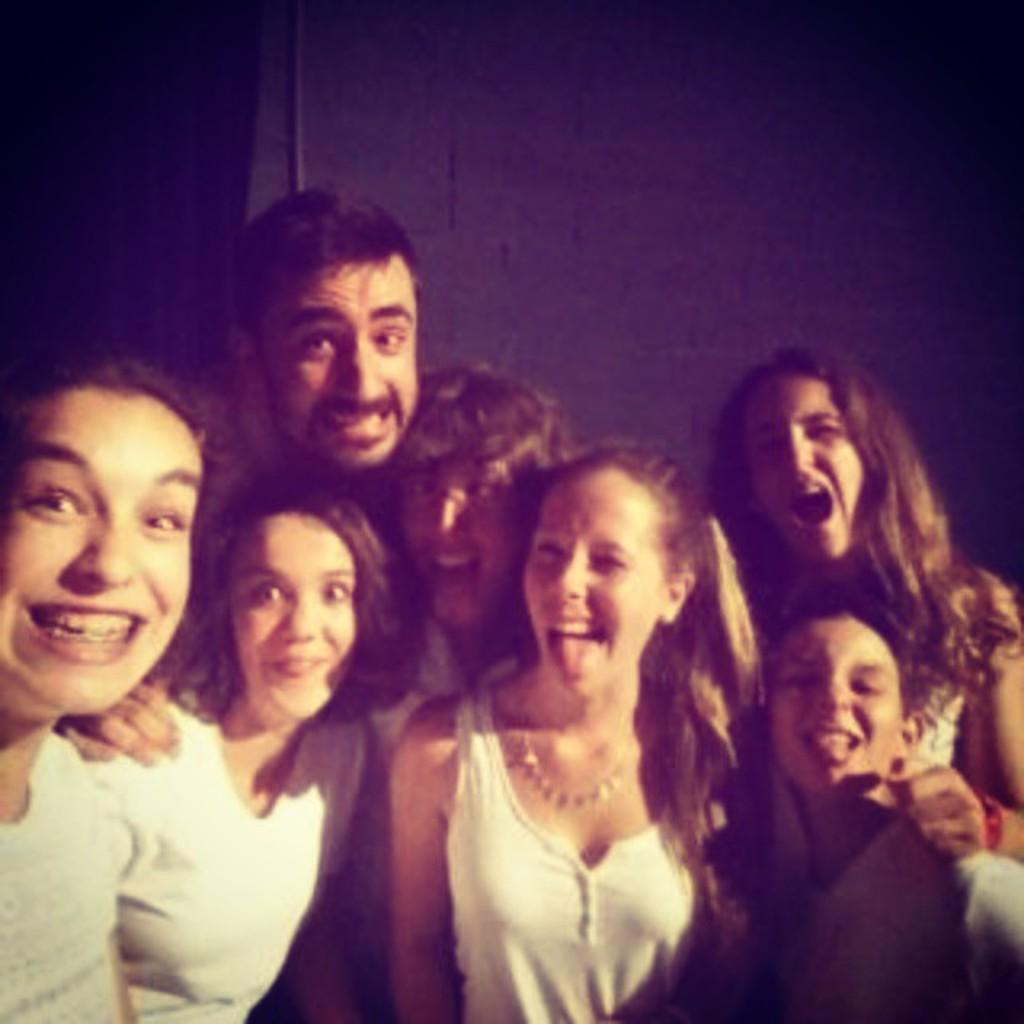What is the main subject of the image? The main subject of the image is people. Where are the people located in the image? The people are in the center of the image. What can be seen in the background of the image? There is a wall in the background of the image. What type of throne is depicted in the image? There is no throne present in the image. What is the opinion of the people in the image about the topic of body language? The image does not provide any information about the people's opinions on body language. 